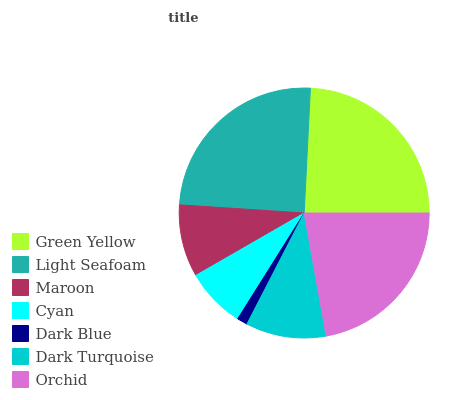Is Dark Blue the minimum?
Answer yes or no. Yes. Is Light Seafoam the maximum?
Answer yes or no. Yes. Is Maroon the minimum?
Answer yes or no. No. Is Maroon the maximum?
Answer yes or no. No. Is Light Seafoam greater than Maroon?
Answer yes or no. Yes. Is Maroon less than Light Seafoam?
Answer yes or no. Yes. Is Maroon greater than Light Seafoam?
Answer yes or no. No. Is Light Seafoam less than Maroon?
Answer yes or no. No. Is Dark Turquoise the high median?
Answer yes or no. Yes. Is Dark Turquoise the low median?
Answer yes or no. Yes. Is Maroon the high median?
Answer yes or no. No. Is Orchid the low median?
Answer yes or no. No. 